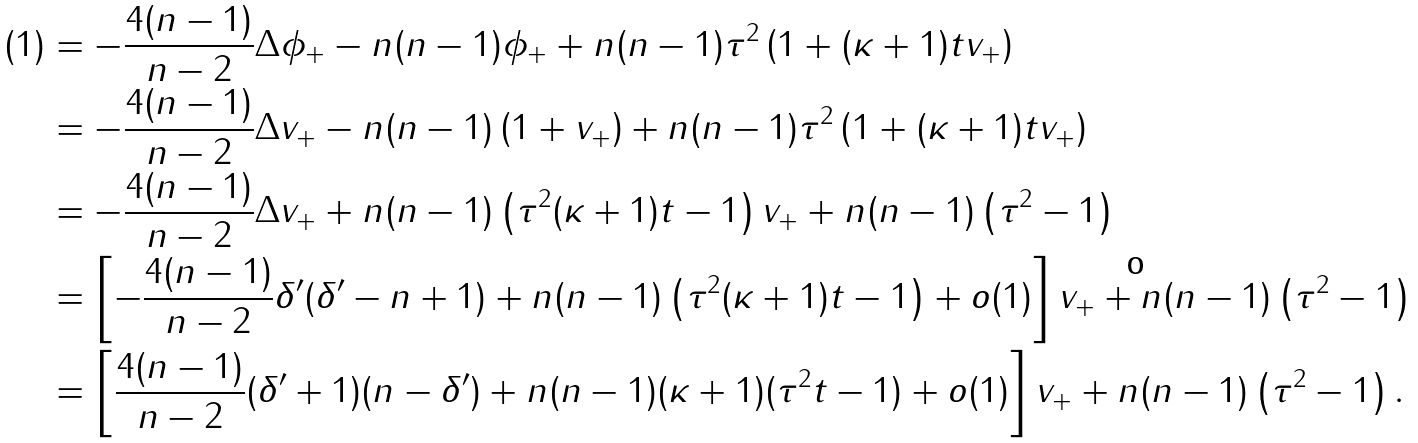Convert formula to latex. <formula><loc_0><loc_0><loc_500><loc_500>( 1 ) & = - \frac { 4 ( n - 1 ) } { n - 2 } \Delta \phi _ { + } - n ( n - 1 ) \phi _ { + } + n ( n - 1 ) \tau ^ { 2 } \left ( 1 + ( \kappa + 1 ) t v _ { + } \right ) \\ & = - \frac { 4 ( n - 1 ) } { n - 2 } \Delta v _ { + } - n ( n - 1 ) \left ( 1 + v _ { + } \right ) + n ( n - 1 ) \tau ^ { 2 } \left ( 1 + ( \kappa + 1 ) t v _ { + } \right ) \\ & = - \frac { 4 ( n - 1 ) } { n - 2 } \Delta v _ { + } + n ( n - 1 ) \left ( \tau ^ { 2 } ( \kappa + 1 ) t - 1 \right ) v _ { + } + n ( n - 1 ) \left ( \tau ^ { 2 } - 1 \right ) \\ & = \left [ - \frac { 4 ( n - 1 ) } { n - 2 } \delta ^ { \prime } ( \delta ^ { \prime } - n + 1 ) + n ( n - 1 ) \left ( \tau ^ { 2 } ( \kappa + 1 ) t - 1 \right ) + o ( 1 ) \right ] v _ { + } + n ( n - 1 ) \left ( \tau ^ { 2 } - 1 \right ) \\ & = \left [ \frac { 4 ( n - 1 ) } { n - 2 } ( \delta ^ { \prime } + 1 ) ( n - \delta ^ { \prime } ) + n ( n - 1 ) ( \kappa + 1 ) ( \tau ^ { 2 } t - 1 ) + o ( 1 ) \right ] v _ { + } + n ( n - 1 ) \left ( \tau ^ { 2 } - 1 \right ) . \\</formula> 